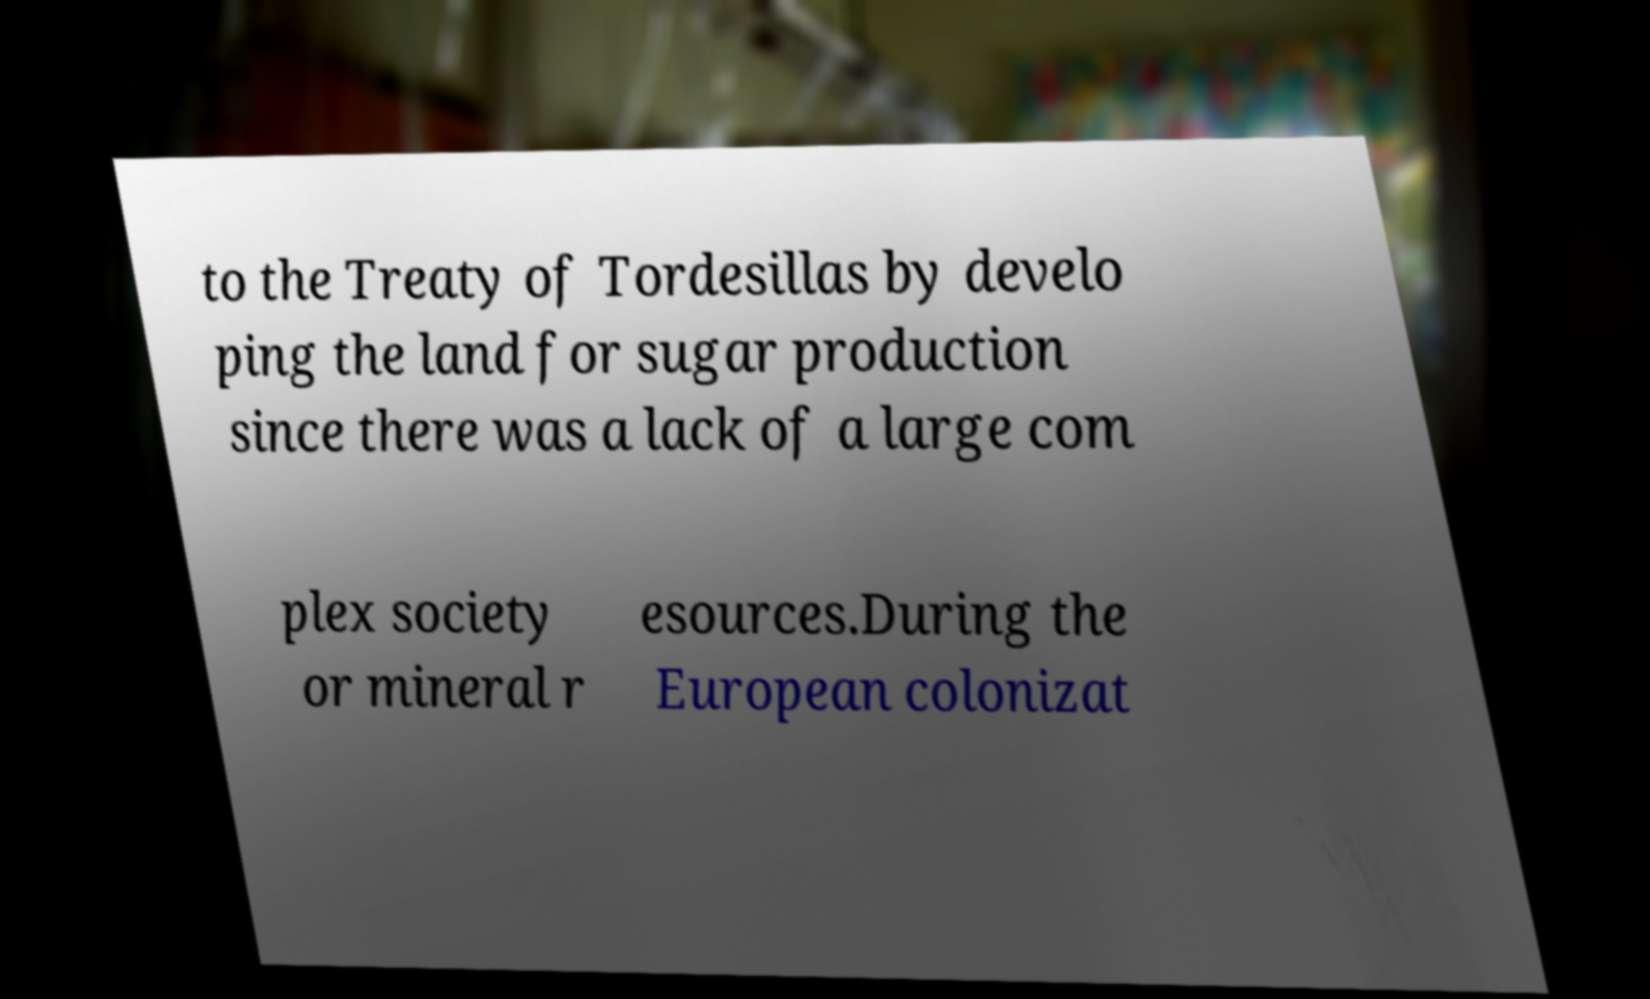There's text embedded in this image that I need extracted. Can you transcribe it verbatim? to the Treaty of Tordesillas by develo ping the land for sugar production since there was a lack of a large com plex society or mineral r esources.During the European colonizat 